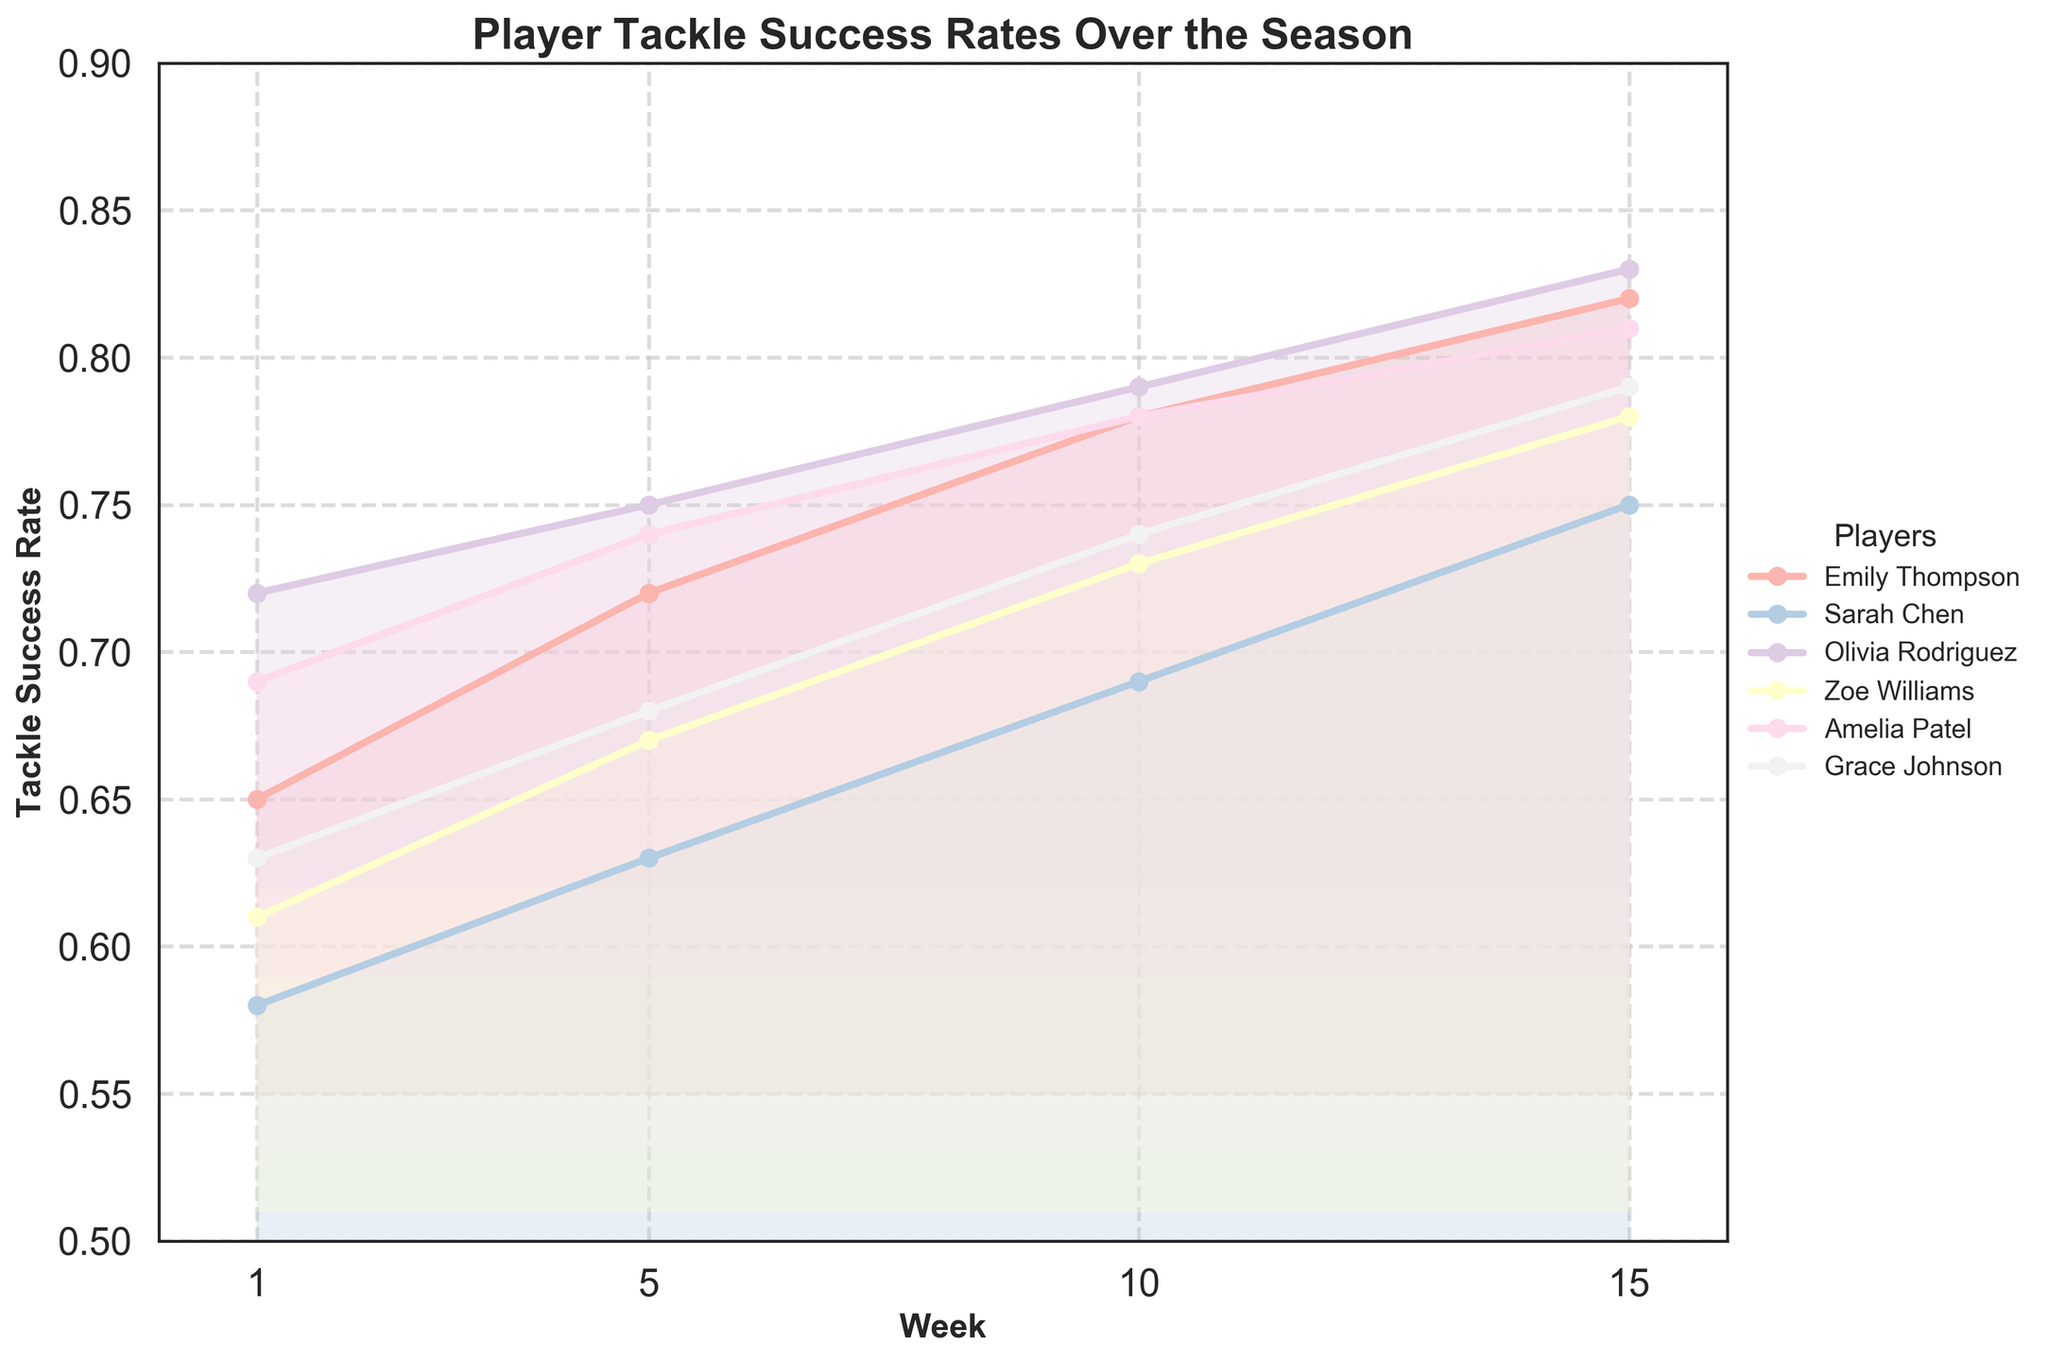Which player has the highest tackle success rate in week 15? By looking at the figure, find the player whose line is highest at week 15. Emily Thompson and Olivia Rodriguez both have the highest tackle success rate at week 15.
Answer: Emily Thompson, Olivia Rodriguez What is the average tackle success rate of Zoe Williams over the season? To find the average, add Zoe Williams' tackle success rates for each week and divide by the number of weeks: (0.61 + 0.67 + 0.73 + 0.78)/4 = 2.79/4 = 0.6975.
Answer: 0.6975 Which player shows the most improvement from week 1 to week 15? Calculate the difference in tackle success rate between week 1 and week 15 for each player and identify the largest difference. Emily Thompson improves by 0.82 - 0.65 = 0.17, which is the most.
Answer: Emily Thompson How does Amelia Patel's performance in week 5 compare to Sarah Chen's performance in week 10? Compare the tackle success rates of Amelia Patel in week 5 and Sarah Chen in week 10. Amelia Patel's rate in week 5 is 0.74, Sarah Chen's rate in week 10 is 0.69.
Answer: Higher What is the common trend observed in the tackle success rate for all players throughout the season? Observe the general direction of the lines for all players from week 1 to week 15. All lines slope upwards indicating an overall improvement.
Answer: Improvement Which player has the least tackle success rate improvement over the season? Calculate the difference in tackle success rate between week 1 and week 15 for each player and identify the smallest difference. Grace Johnson improves by 0.79 - 0.63 = 0.16, which is the smallest.
Answer: Grace Johnson How many players have their highest tackle success rate in week 10? Check the plot to see if any player's line peaks at week 10. None of the players have their peak tackle success rate at week 10.
Answer: None What is the overall tackle success rate range for Olivia Rodriguez from week 1 to week 15? Identify the minimum and maximum points of Olivia Rodriguez's line in the plot. Her tackle success rate ranges from 0.72 to 0.83.
Answer: 0.72 to 0.83 Which player has an evident dip in their tackle success rate at any point in the season? Scan the lines of each player to see if any line dips before rising again; none of the players show a dip before the end.
Answer: None Who has a better tackle success rate at the beginning of the season, Sarah Chen or Zoe Williams? Compare the tackle success rates of Sarah Chen and Zoe Williams in week 1. Sarah Chen has a rate of 0.58 while Zoe Williams has a rate of 0.61.
Answer: Zoe Williams 